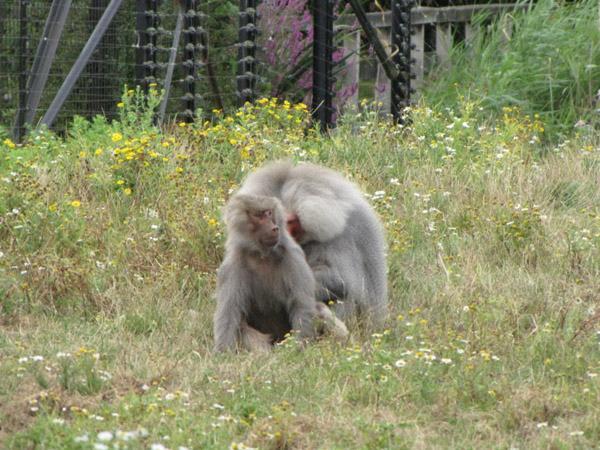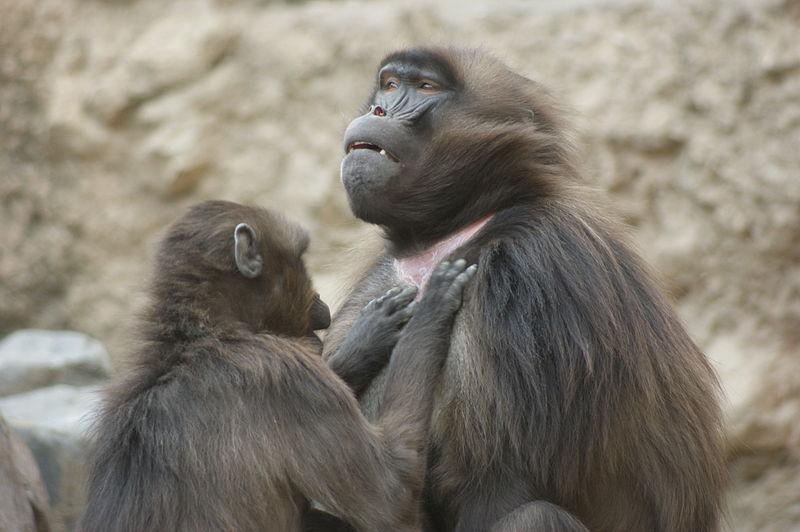The first image is the image on the left, the second image is the image on the right. Analyze the images presented: Is the assertion "No image contains more than three monkeys, and one image shows a monkey with both paws grooming the fur of the monkey next to it." valid? Answer yes or no. Yes. The first image is the image on the left, the second image is the image on the right. Given the left and right images, does the statement "There are exactly two animals visible in the right image." hold true? Answer yes or no. Yes. 